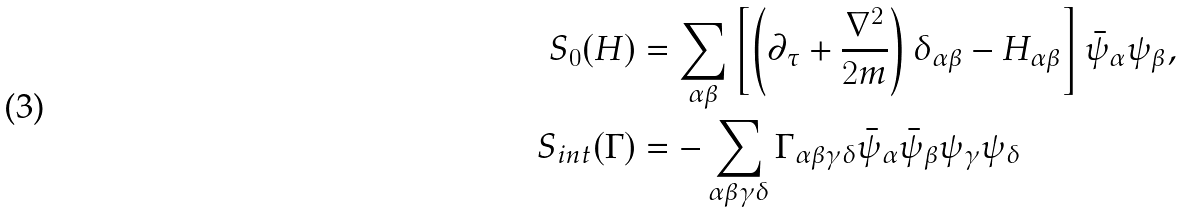<formula> <loc_0><loc_0><loc_500><loc_500>S _ { 0 } ( H ) & = \sum _ { \alpha \beta } \left [ \left ( \partial _ { \tau } + \frac { \nabla ^ { 2 } } { 2 m } \right ) \delta _ { \alpha \beta } - H _ { \alpha \beta } \right ] \bar { \psi } _ { \alpha } \psi _ { \beta } , \\ S _ { i n t } ( \Gamma ) & = - \sum _ { \alpha \beta \gamma \delta } \Gamma _ { \alpha \beta \gamma \delta } \bar { \psi } _ { \alpha } \bar { \psi } _ { \beta } \psi _ { \gamma } \psi _ { \delta }</formula> 